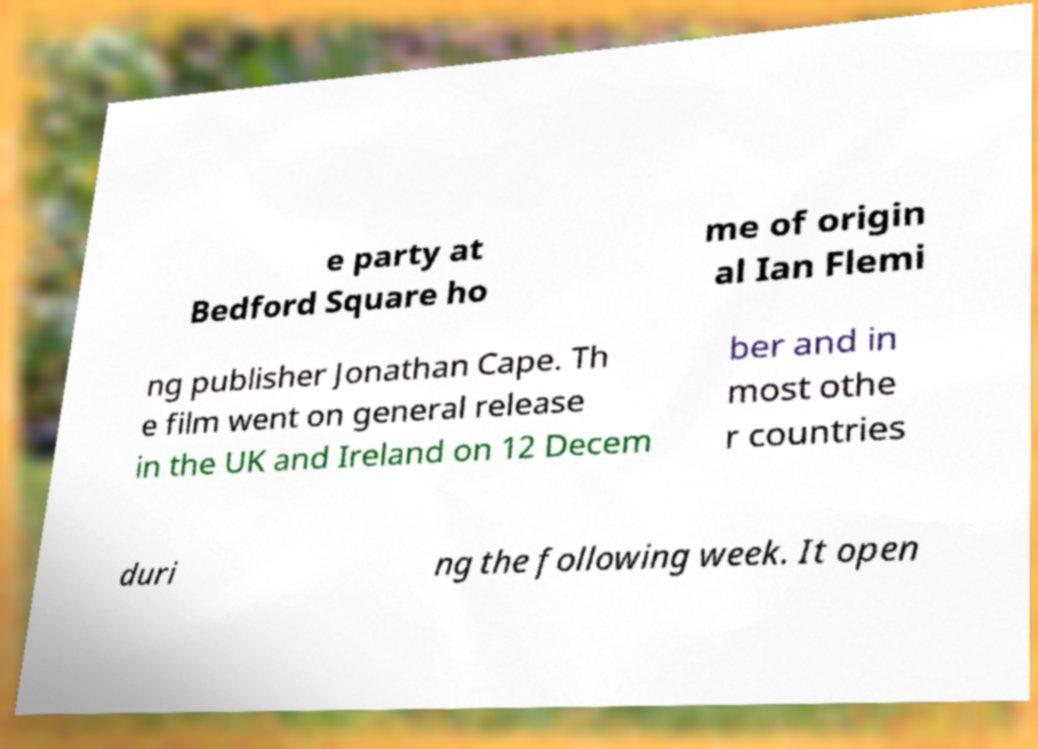Can you accurately transcribe the text from the provided image for me? e party at Bedford Square ho me of origin al Ian Flemi ng publisher Jonathan Cape. Th e film went on general release in the UK and Ireland on 12 Decem ber and in most othe r countries duri ng the following week. It open 